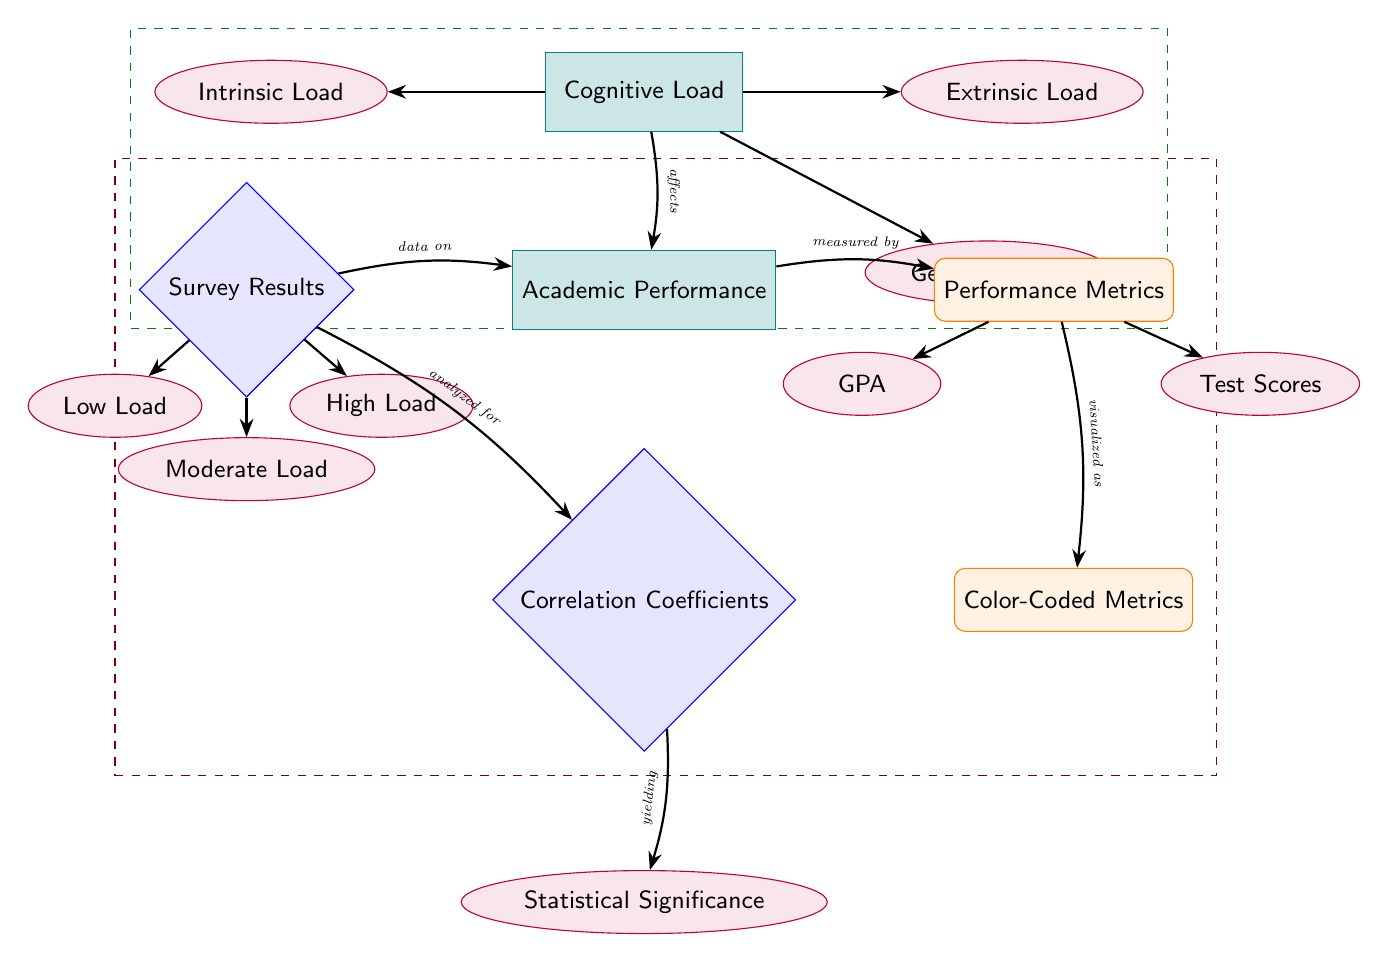What's the top node in the diagram? The top node in the diagram is "Cognitive Load," which is the starting point for understanding the relationships illustrated regarding academic performance.
Answer: Cognitive Load How many sub-types of cognitive load are indicated? There are three sub-types of cognitive load indicated in the diagram: "Intrinsic Load," "Extrinsic Load," and "Germane Load."
Answer: Three What does "Cognitive Load" affect according to the diagram? According to the diagram, "Cognitive Load" affects "Academic Performance," shown by the arrow connecting these two nodes.
Answer: Academic Performance Which performance metrics are measured in the diagram? The performance metrics measured in the diagram are "GPA" and "Test Scores," both directly linked as sub-nodes of the "Performance Metrics" node.
Answer: GPA and Test Scores What type of results does the "Survey Results" node provide? The "Survey Results" node provides data categorized into three levels: "Low Load," "Moderate Load," and "High Load," which indicate different levels of cognitive load reported by survey respondents.
Answer: Data on cognitive load levels How are correlation coefficients related to statistical significance in the diagram? Correlation coefficients are analyzed for statistical significance, which is depicted with a direct link between the "Correlation Coefficients" node and the "Statistical Significance" node, indicating that significance is derived from correlations.
Answer: Analyzed for statistical significance What color represents the performance metrics in the diagram? The performance metrics are represented in orange, as indicated by the "Performance Metrics" node being filled with orange color.
Answer: Orange What do the dashed green and red rectangles around the nodes indicate? The dashed green rectangle surrounds cognitive load nodes, indicating a thematic grouping related to cognitive load, while the dashed red rectangle surrounds the academic performance-related nodes, representing a separate grouping concerning performance outcomes.
Answer: Thematic groupings What is visualized as color-coded metrics in the diagram? The "Color-Coded Metrics" node illustrates that the performance metrics are visualized in a manner that uses color coding to represent differing performance outcomes or levels, linked directly from the "Performance Metrics" node.
Answer: Performance metrics Which node provides information on the nature of the data collected? The "Survey Results" node provides information about the nature of the data collected, marked as the entry point for analyzing how cognitive load influences academic performance.
Answer: Survey Results 